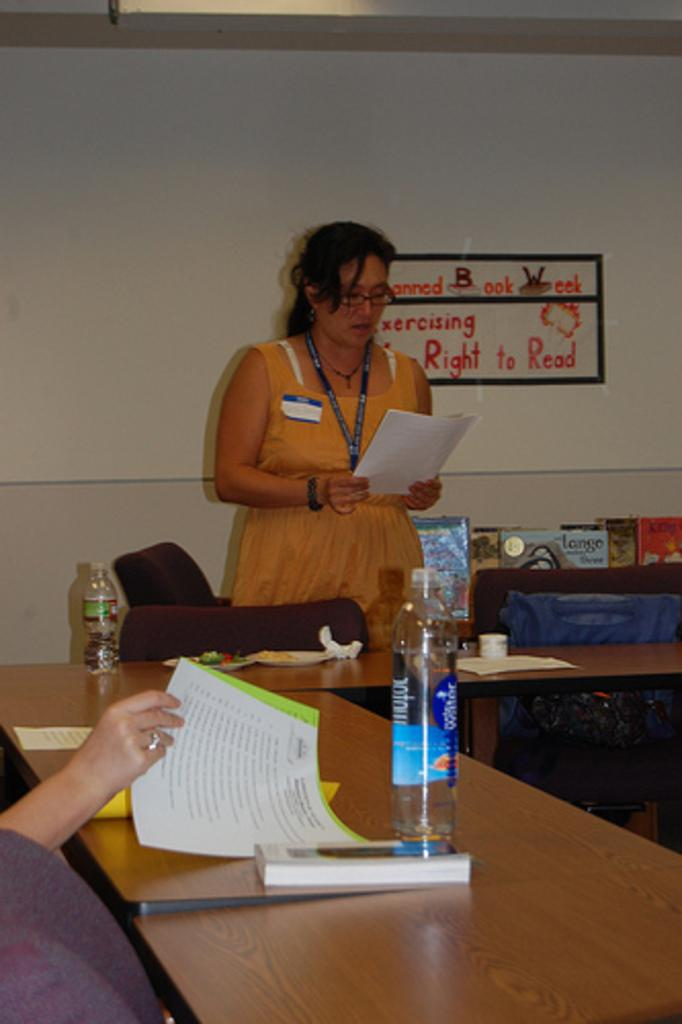What is the woman in the image doing? The woman is standing in the image and holding papers in her hand. What is on the table in front of the woman? There is a bottle, papers, and other objects on the table. What is the background of the scene? There is a wall at the back of the scene. What type of dock can be seen in the image? There is no dock present in the image. What kind of stew is being prepared on the table in the image? There is no stew or cooking activity depicted in the image. 